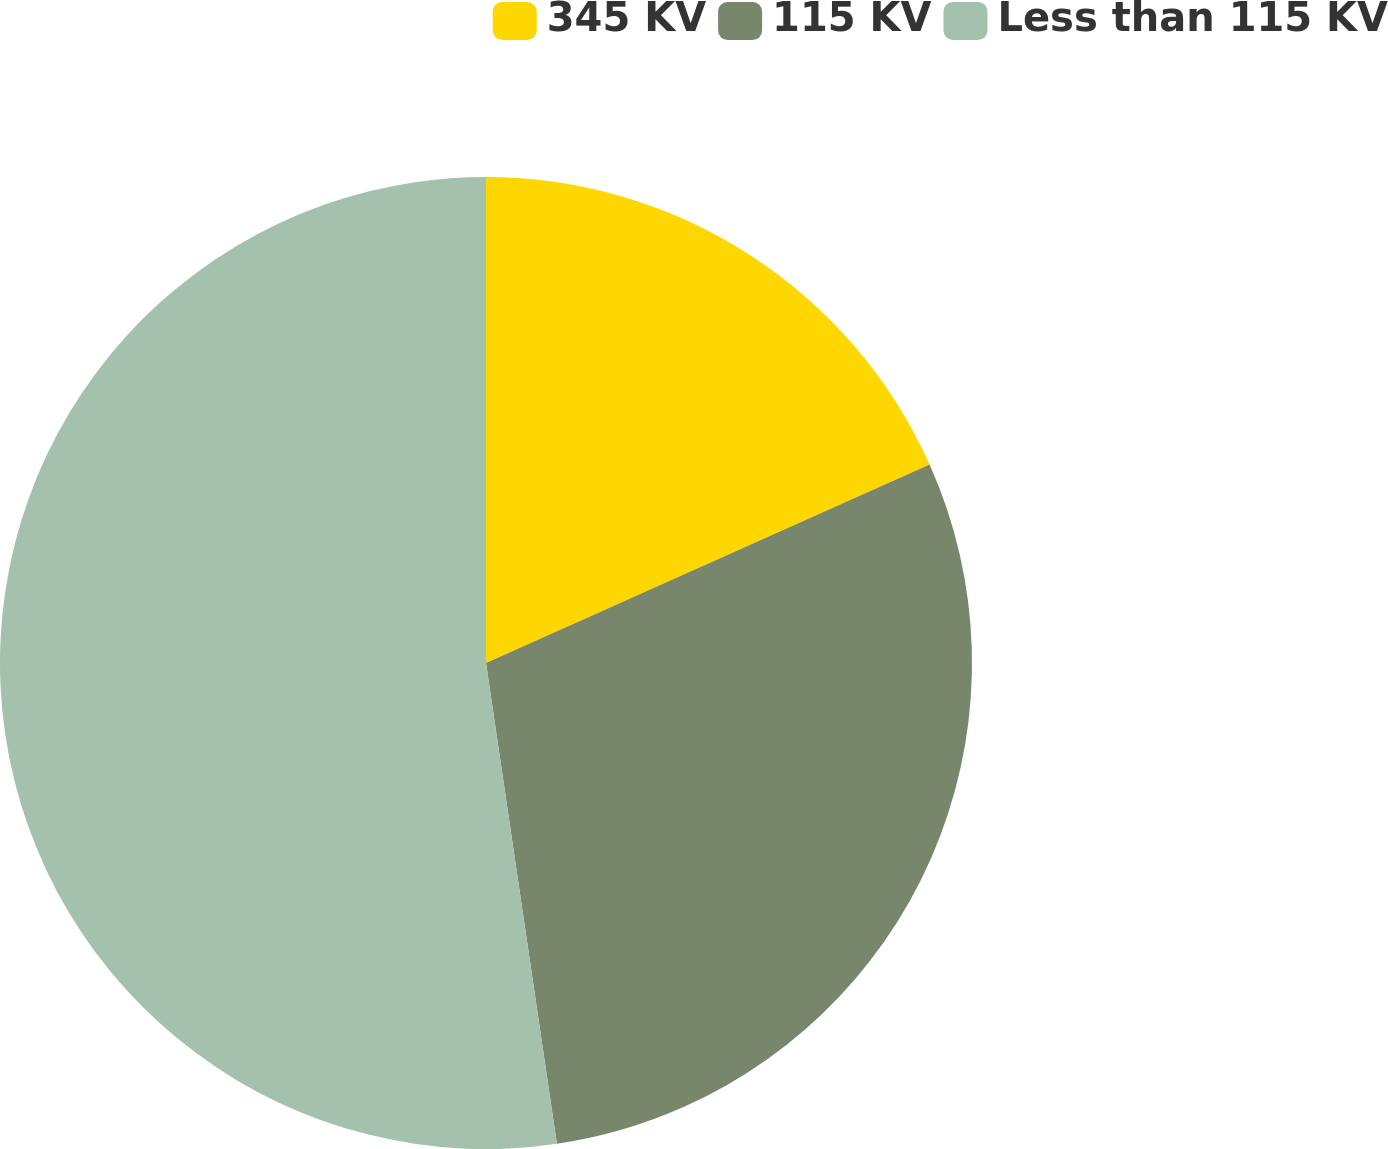Convert chart to OTSL. <chart><loc_0><loc_0><loc_500><loc_500><pie_chart><fcel>345 KV<fcel>115 KV<fcel>Less than 115 KV<nl><fcel>18.3%<fcel>29.37%<fcel>52.33%<nl></chart> 